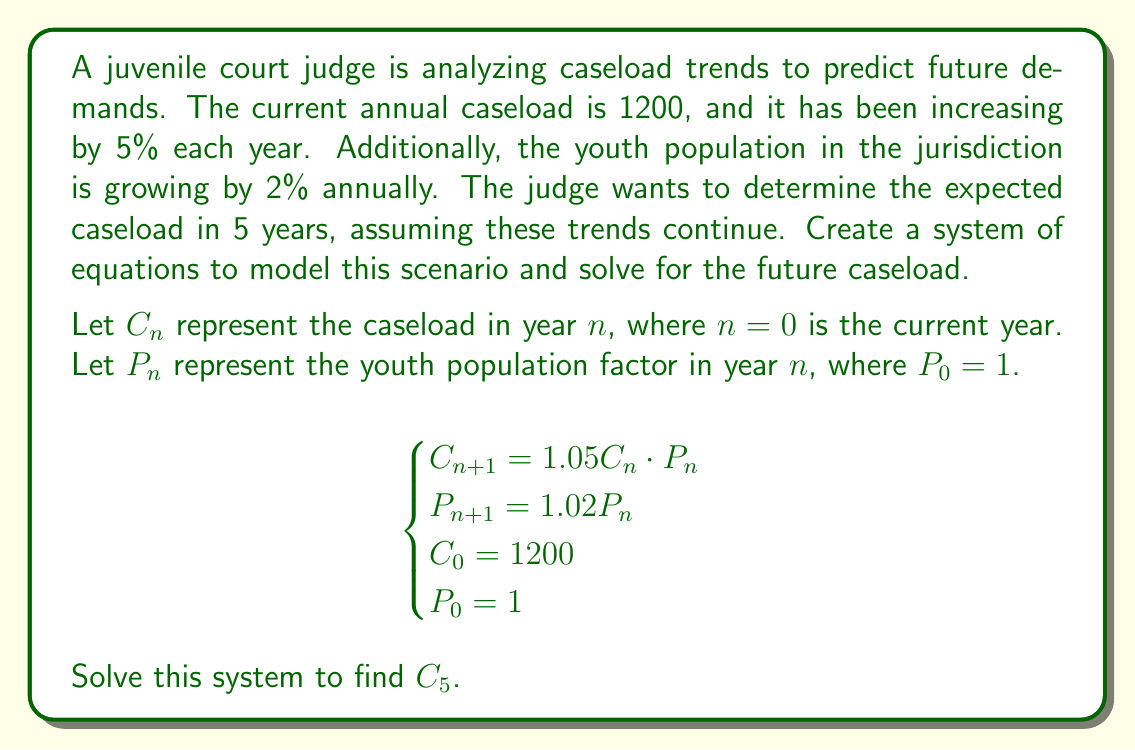What is the answer to this math problem? To solve this system of equations, we'll follow these steps:

1) First, let's solve for $P_n$ in terms of $n$:
   $P_1 = 1.02P_0 = 1.02$
   $P_2 = 1.02P_1 = 1.02 \cdot 1.02 = (1.02)^2$
   
   We can see that $P_n = (1.02)^n$

2) Now, let's solve for $C_n$:
   $C_1 = 1.05C_0 \cdot P_0 = 1.05 \cdot 1200 \cdot 1 = 1260$
   $C_2 = 1.05C_1 \cdot P_1 = 1.05 \cdot 1260 \cdot 1.02 = 1346.76$
   
   We can express this generally as:
   $C_n = 1200 \cdot (1.05)^n \cdot (1.02)^{\frac{n(n-1)}{2}}$

3) To find $C_5$, we plug in $n = 5$:
   $C_5 = 1200 \cdot (1.05)^5 \cdot (1.02)^{\frac{5(5-1)}{2}}$
   $= 1200 \cdot (1.05)^5 \cdot (1.02)^{10}$
   $= 1200 \cdot 1.2762815625 \cdot 1.2189944352$
   $\approx 1867.37$

Therefore, the expected caseload in 5 years is approximately 1867 cases.
Answer: The expected caseload in 5 years is approximately 1867 cases. 